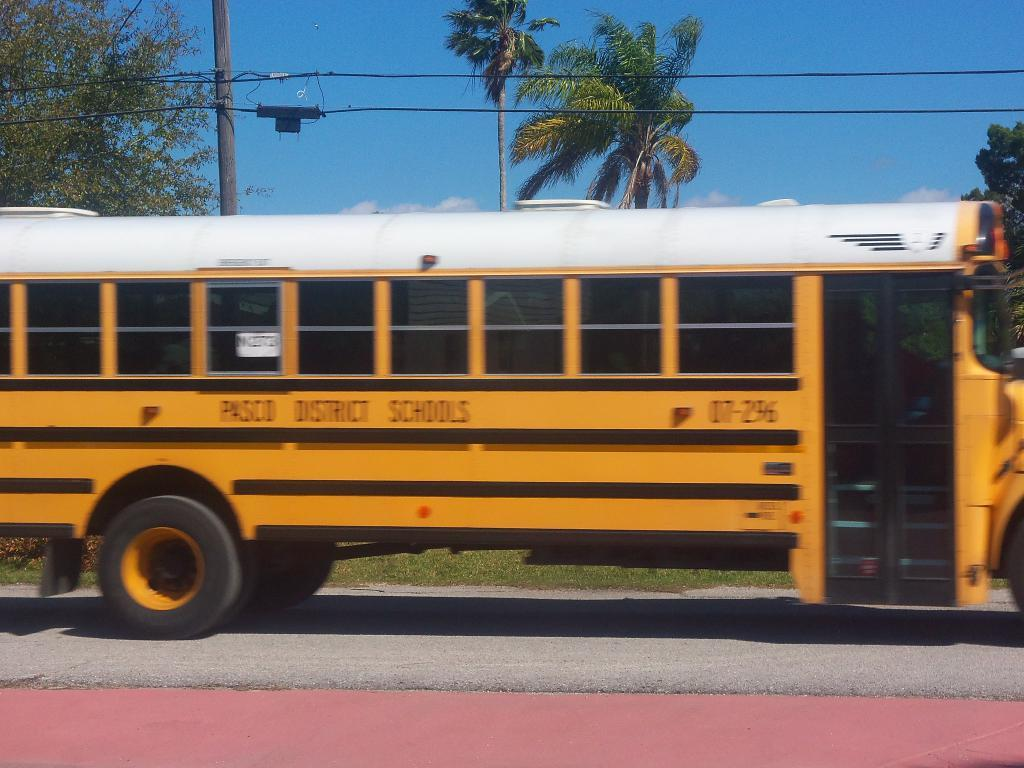What type of vehicle is in the image? There is a school bus in the image. Where is the school bus located? The school bus is on a road. What can be seen behind the bus? There is a pole, wires, trees, and grass behind the bus. Can you tell me how many dimes are scattered on the grass behind the bus? There is no mention of dimes in the image, so it is not possible to determine their presence or quantity. 